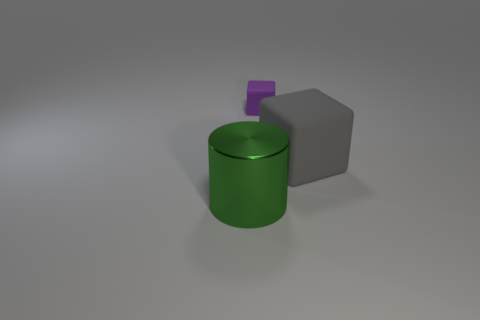What could be the size relationship between the objects based on their appearance? The image suggests that the green cylinder is the largest of the three objects in both height and diameter. The gray cube appears to be of moderate size, smaller than the cylinder but with a significant presence. Lastly, the purple cube is much smaller, almost like a diminutive addition to the assembly, which adds an interesting dynamic to the overall scale of the objects. 